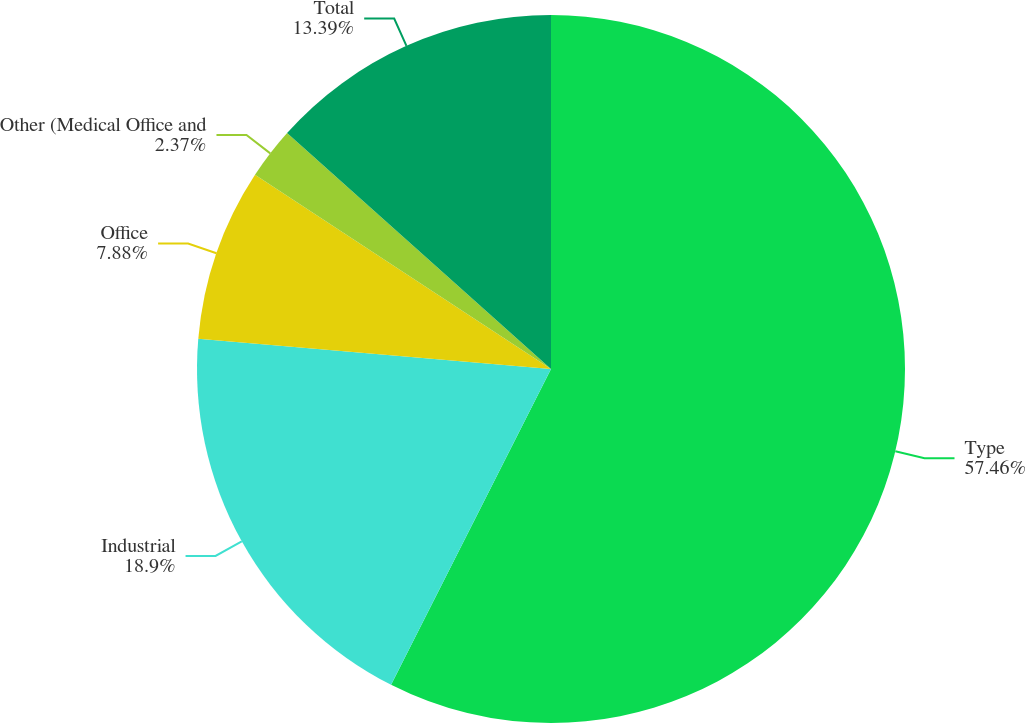Convert chart to OTSL. <chart><loc_0><loc_0><loc_500><loc_500><pie_chart><fcel>Type<fcel>Industrial<fcel>Office<fcel>Other (Medical Office and<fcel>Total<nl><fcel>57.46%<fcel>18.9%<fcel>7.88%<fcel>2.37%<fcel>13.39%<nl></chart> 